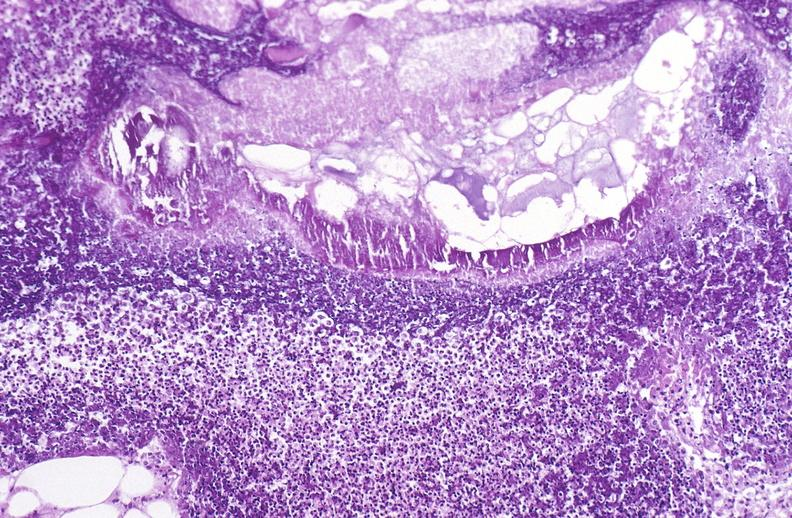does this image show pancreatic fat necrosis?
Answer the question using a single word or phrase. Yes 